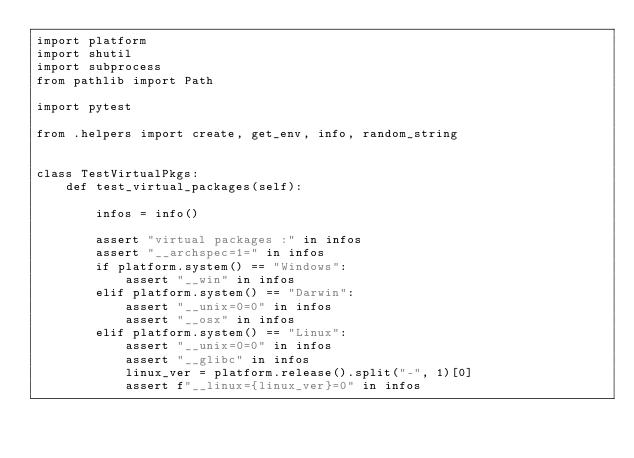<code> <loc_0><loc_0><loc_500><loc_500><_Python_>import platform
import shutil
import subprocess
from pathlib import Path

import pytest

from .helpers import create, get_env, info, random_string


class TestVirtualPkgs:
    def test_virtual_packages(self):

        infos = info()

        assert "virtual packages :" in infos
        assert "__archspec=1=" in infos
        if platform.system() == "Windows":
            assert "__win" in infos
        elif platform.system() == "Darwin":
            assert "__unix=0=0" in infos
            assert "__osx" in infos
        elif platform.system() == "Linux":
            assert "__unix=0=0" in infos
            assert "__glibc" in infos
            linux_ver = platform.release().split("-", 1)[0]
            assert f"__linux={linux_ver}=0" in infos
</code> 